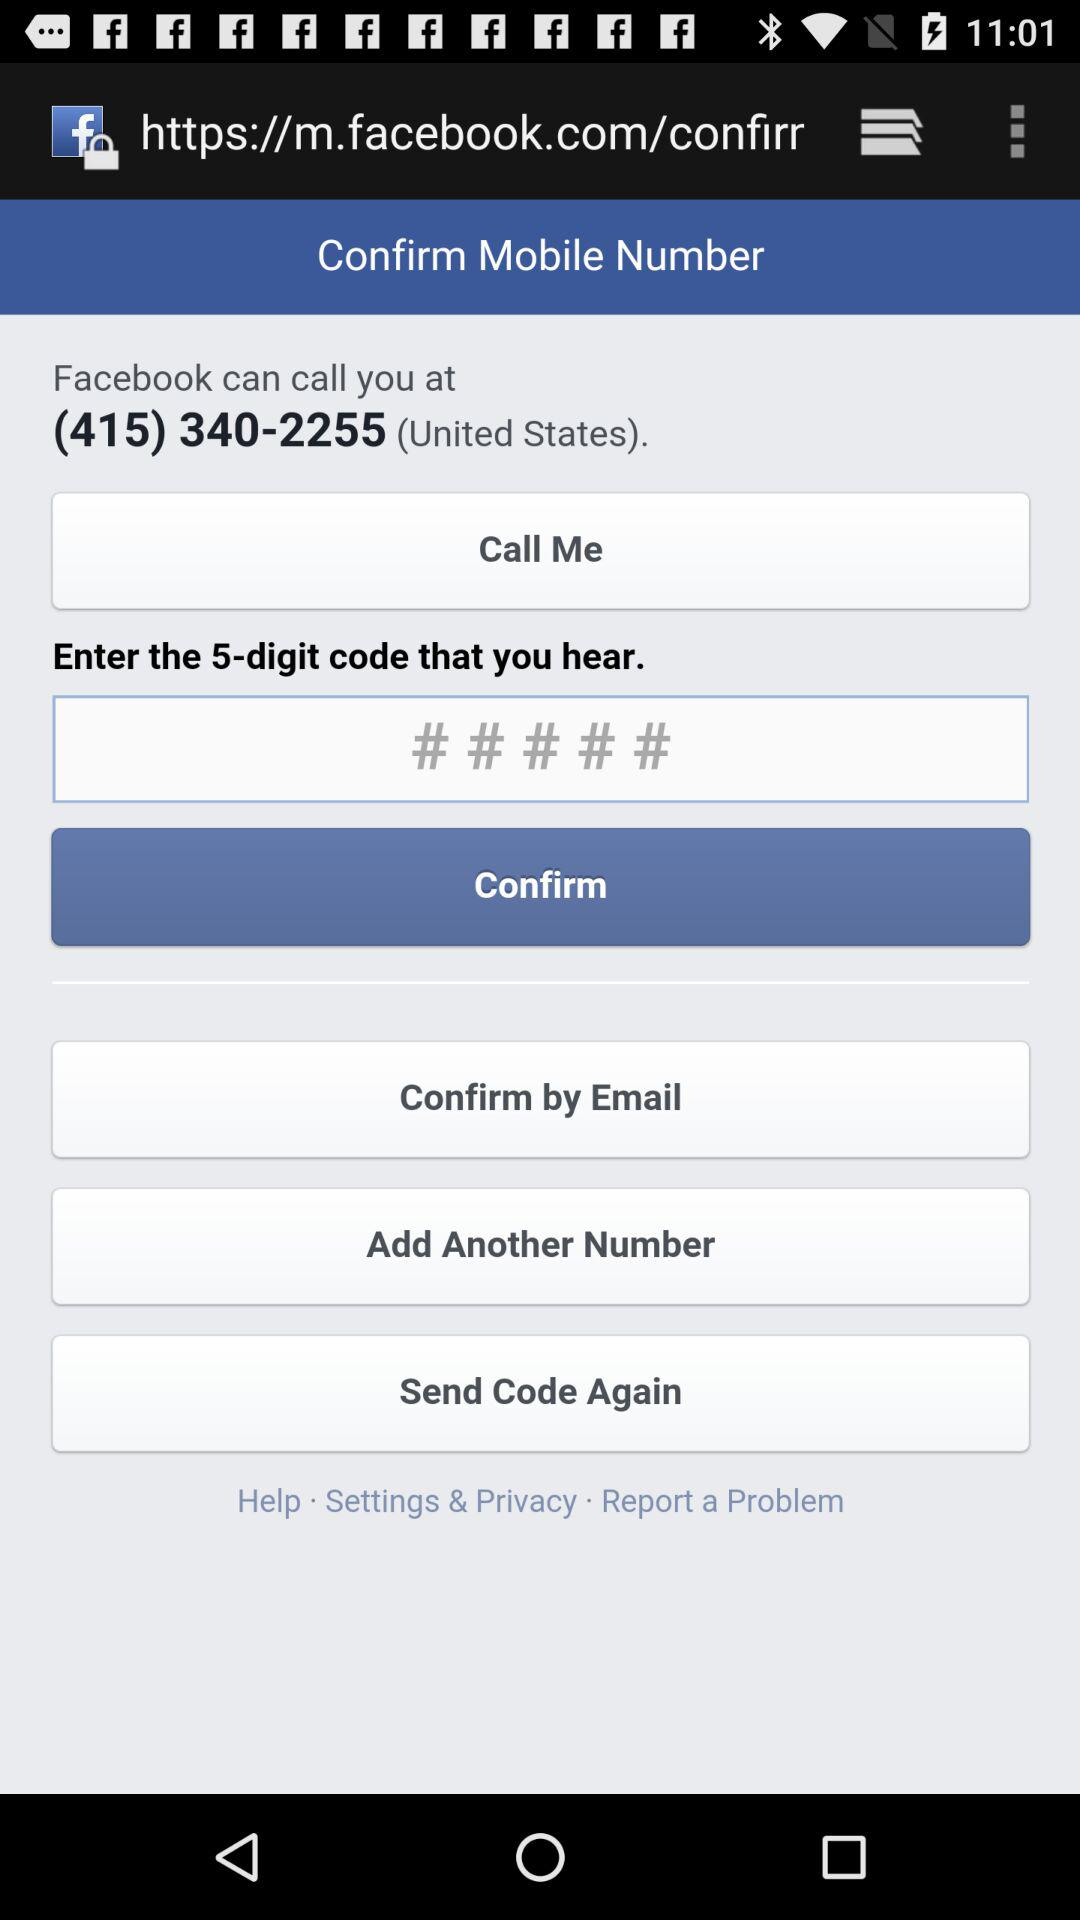How many numbers are in the code?
Answer the question using a single word or phrase. 5 